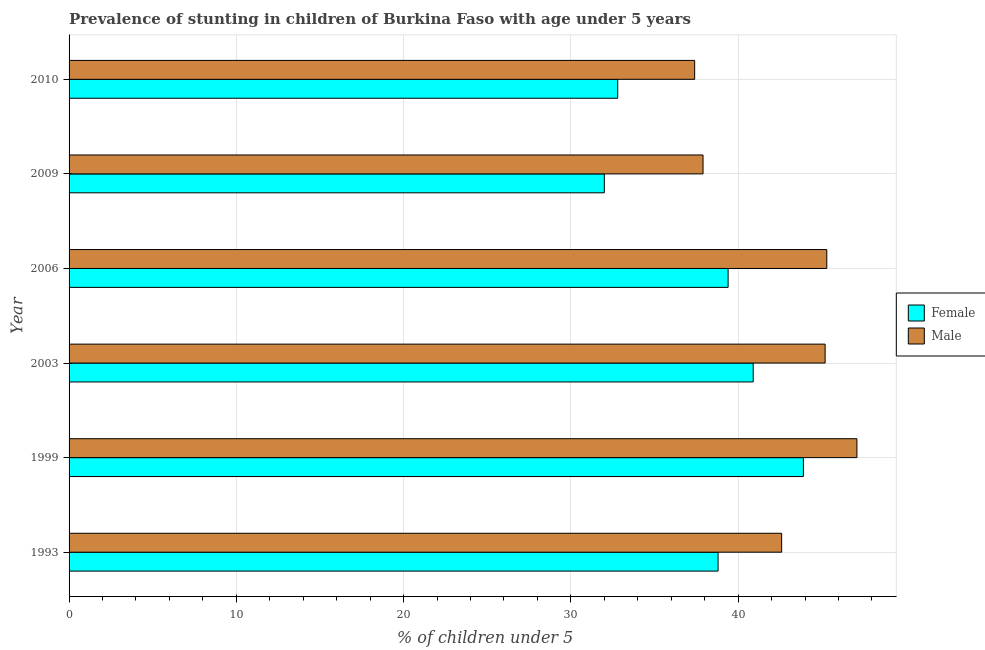How many groups of bars are there?
Offer a terse response. 6. Are the number of bars per tick equal to the number of legend labels?
Offer a very short reply. Yes. How many bars are there on the 2nd tick from the bottom?
Your answer should be very brief. 2. What is the percentage of stunted male children in 2009?
Provide a short and direct response. 37.9. Across all years, what is the maximum percentage of stunted male children?
Give a very brief answer. 47.1. Across all years, what is the minimum percentage of stunted female children?
Your answer should be compact. 32. In which year was the percentage of stunted male children maximum?
Provide a succinct answer. 1999. What is the total percentage of stunted male children in the graph?
Ensure brevity in your answer.  255.5. What is the difference between the percentage of stunted female children in 1999 and that in 2003?
Provide a short and direct response. 3. What is the difference between the percentage of stunted female children in 2003 and the percentage of stunted male children in 2006?
Your answer should be compact. -4.4. What is the average percentage of stunted male children per year?
Provide a succinct answer. 42.58. In the year 1999, what is the difference between the percentage of stunted female children and percentage of stunted male children?
Give a very brief answer. -3.2. What is the ratio of the percentage of stunted female children in 1993 to that in 2009?
Offer a very short reply. 1.21. Is the percentage of stunted female children in 1999 less than that in 2006?
Offer a very short reply. No. Is the difference between the percentage of stunted male children in 2009 and 2010 greater than the difference between the percentage of stunted female children in 2009 and 2010?
Provide a short and direct response. Yes. What does the 1st bar from the top in 2010 represents?
Give a very brief answer. Male. What does the 1st bar from the bottom in 1999 represents?
Provide a succinct answer. Female. How many years are there in the graph?
Offer a very short reply. 6. Does the graph contain any zero values?
Your response must be concise. No. How many legend labels are there?
Your response must be concise. 2. What is the title of the graph?
Provide a succinct answer. Prevalence of stunting in children of Burkina Faso with age under 5 years. What is the label or title of the X-axis?
Make the answer very short.  % of children under 5. What is the  % of children under 5 in Female in 1993?
Your answer should be very brief. 38.8. What is the  % of children under 5 in Male in 1993?
Offer a very short reply. 42.6. What is the  % of children under 5 of Female in 1999?
Keep it short and to the point. 43.9. What is the  % of children under 5 of Male in 1999?
Give a very brief answer. 47.1. What is the  % of children under 5 of Female in 2003?
Provide a succinct answer. 40.9. What is the  % of children under 5 of Male in 2003?
Your answer should be compact. 45.2. What is the  % of children under 5 of Female in 2006?
Offer a terse response. 39.4. What is the  % of children under 5 of Male in 2006?
Offer a very short reply. 45.3. What is the  % of children under 5 of Female in 2009?
Your answer should be compact. 32. What is the  % of children under 5 in Male in 2009?
Keep it short and to the point. 37.9. What is the  % of children under 5 of Female in 2010?
Ensure brevity in your answer.  32.8. What is the  % of children under 5 of Male in 2010?
Ensure brevity in your answer.  37.4. Across all years, what is the maximum  % of children under 5 in Female?
Provide a short and direct response. 43.9. Across all years, what is the maximum  % of children under 5 in Male?
Provide a short and direct response. 47.1. Across all years, what is the minimum  % of children under 5 in Male?
Provide a short and direct response. 37.4. What is the total  % of children under 5 in Female in the graph?
Offer a very short reply. 227.8. What is the total  % of children under 5 in Male in the graph?
Your response must be concise. 255.5. What is the difference between the  % of children under 5 of Male in 1993 and that in 1999?
Your answer should be compact. -4.5. What is the difference between the  % of children under 5 in Female in 1993 and that in 2003?
Your response must be concise. -2.1. What is the difference between the  % of children under 5 in Male in 1993 and that in 2009?
Your answer should be very brief. 4.7. What is the difference between the  % of children under 5 in Female in 1993 and that in 2010?
Provide a short and direct response. 6. What is the difference between the  % of children under 5 in Female in 1999 and that in 2003?
Offer a very short reply. 3. What is the difference between the  % of children under 5 in Female in 1999 and that in 2006?
Your answer should be compact. 4.5. What is the difference between the  % of children under 5 of Male in 1999 and that in 2006?
Provide a short and direct response. 1.8. What is the difference between the  % of children under 5 of Female in 1999 and that in 2009?
Provide a short and direct response. 11.9. What is the difference between the  % of children under 5 in Male in 1999 and that in 2009?
Make the answer very short. 9.2. What is the difference between the  % of children under 5 in Female in 1999 and that in 2010?
Ensure brevity in your answer.  11.1. What is the difference between the  % of children under 5 in Male in 1999 and that in 2010?
Offer a very short reply. 9.7. What is the difference between the  % of children under 5 of Female in 2003 and that in 2006?
Your answer should be very brief. 1.5. What is the difference between the  % of children under 5 of Male in 2003 and that in 2006?
Give a very brief answer. -0.1. What is the difference between the  % of children under 5 of Male in 2003 and that in 2009?
Offer a terse response. 7.3. What is the difference between the  % of children under 5 in Female in 2003 and that in 2010?
Provide a short and direct response. 8.1. What is the difference between the  % of children under 5 of Male in 2003 and that in 2010?
Your answer should be very brief. 7.8. What is the difference between the  % of children under 5 of Male in 2006 and that in 2010?
Keep it short and to the point. 7.9. What is the difference between the  % of children under 5 in Female in 2009 and that in 2010?
Make the answer very short. -0.8. What is the difference between the  % of children under 5 in Female in 1993 and the  % of children under 5 in Male in 2003?
Offer a terse response. -6.4. What is the difference between the  % of children under 5 in Female in 1993 and the  % of children under 5 in Male in 2009?
Give a very brief answer. 0.9. What is the difference between the  % of children under 5 of Female in 2003 and the  % of children under 5 of Male in 2006?
Make the answer very short. -4.4. What is the difference between the  % of children under 5 in Female in 2006 and the  % of children under 5 in Male in 2010?
Keep it short and to the point. 2. What is the average  % of children under 5 in Female per year?
Keep it short and to the point. 37.97. What is the average  % of children under 5 of Male per year?
Provide a succinct answer. 42.58. In the year 2010, what is the difference between the  % of children under 5 of Female and  % of children under 5 of Male?
Keep it short and to the point. -4.6. What is the ratio of the  % of children under 5 in Female in 1993 to that in 1999?
Your answer should be compact. 0.88. What is the ratio of the  % of children under 5 of Male in 1993 to that in 1999?
Provide a succinct answer. 0.9. What is the ratio of the  % of children under 5 of Female in 1993 to that in 2003?
Your answer should be compact. 0.95. What is the ratio of the  % of children under 5 of Male in 1993 to that in 2003?
Your answer should be very brief. 0.94. What is the ratio of the  % of children under 5 of Female in 1993 to that in 2006?
Keep it short and to the point. 0.98. What is the ratio of the  % of children under 5 of Male in 1993 to that in 2006?
Your answer should be very brief. 0.94. What is the ratio of the  % of children under 5 of Female in 1993 to that in 2009?
Keep it short and to the point. 1.21. What is the ratio of the  % of children under 5 in Male in 1993 to that in 2009?
Ensure brevity in your answer.  1.12. What is the ratio of the  % of children under 5 in Female in 1993 to that in 2010?
Make the answer very short. 1.18. What is the ratio of the  % of children under 5 in Male in 1993 to that in 2010?
Your response must be concise. 1.14. What is the ratio of the  % of children under 5 in Female in 1999 to that in 2003?
Offer a very short reply. 1.07. What is the ratio of the  % of children under 5 in Male in 1999 to that in 2003?
Your response must be concise. 1.04. What is the ratio of the  % of children under 5 of Female in 1999 to that in 2006?
Give a very brief answer. 1.11. What is the ratio of the  % of children under 5 in Male in 1999 to that in 2006?
Your answer should be very brief. 1.04. What is the ratio of the  % of children under 5 of Female in 1999 to that in 2009?
Your response must be concise. 1.37. What is the ratio of the  % of children under 5 of Male in 1999 to that in 2009?
Offer a terse response. 1.24. What is the ratio of the  % of children under 5 of Female in 1999 to that in 2010?
Offer a very short reply. 1.34. What is the ratio of the  % of children under 5 in Male in 1999 to that in 2010?
Provide a short and direct response. 1.26. What is the ratio of the  % of children under 5 in Female in 2003 to that in 2006?
Give a very brief answer. 1.04. What is the ratio of the  % of children under 5 of Female in 2003 to that in 2009?
Offer a terse response. 1.28. What is the ratio of the  % of children under 5 of Male in 2003 to that in 2009?
Offer a very short reply. 1.19. What is the ratio of the  % of children under 5 of Female in 2003 to that in 2010?
Your response must be concise. 1.25. What is the ratio of the  % of children under 5 of Male in 2003 to that in 2010?
Your answer should be compact. 1.21. What is the ratio of the  % of children under 5 in Female in 2006 to that in 2009?
Offer a very short reply. 1.23. What is the ratio of the  % of children under 5 in Male in 2006 to that in 2009?
Make the answer very short. 1.2. What is the ratio of the  % of children under 5 of Female in 2006 to that in 2010?
Keep it short and to the point. 1.2. What is the ratio of the  % of children under 5 of Male in 2006 to that in 2010?
Your answer should be very brief. 1.21. What is the ratio of the  % of children under 5 in Female in 2009 to that in 2010?
Your answer should be very brief. 0.98. What is the ratio of the  % of children under 5 of Male in 2009 to that in 2010?
Keep it short and to the point. 1.01. What is the difference between the highest and the second highest  % of children under 5 of Male?
Keep it short and to the point. 1.8. What is the difference between the highest and the lowest  % of children under 5 in Female?
Give a very brief answer. 11.9. What is the difference between the highest and the lowest  % of children under 5 of Male?
Make the answer very short. 9.7. 